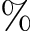<formula> <loc_0><loc_0><loc_500><loc_500>\%</formula> 